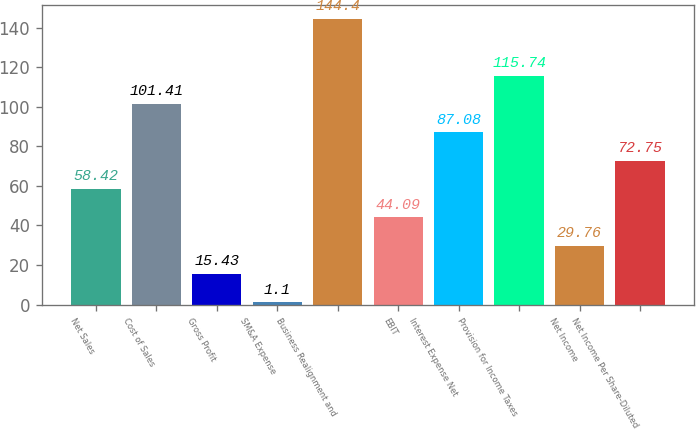Convert chart. <chart><loc_0><loc_0><loc_500><loc_500><bar_chart><fcel>Net Sales<fcel>Cost of Sales<fcel>Gross Profit<fcel>SM&A Expense<fcel>Business Realignment and<fcel>EBIT<fcel>Interest Expense Net<fcel>Provision for Income Taxes<fcel>Net Income<fcel>Net Income Per Share-Diluted<nl><fcel>58.42<fcel>101.41<fcel>15.43<fcel>1.1<fcel>144.4<fcel>44.09<fcel>87.08<fcel>115.74<fcel>29.76<fcel>72.75<nl></chart> 